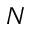<formula> <loc_0><loc_0><loc_500><loc_500>_ { N }</formula> 